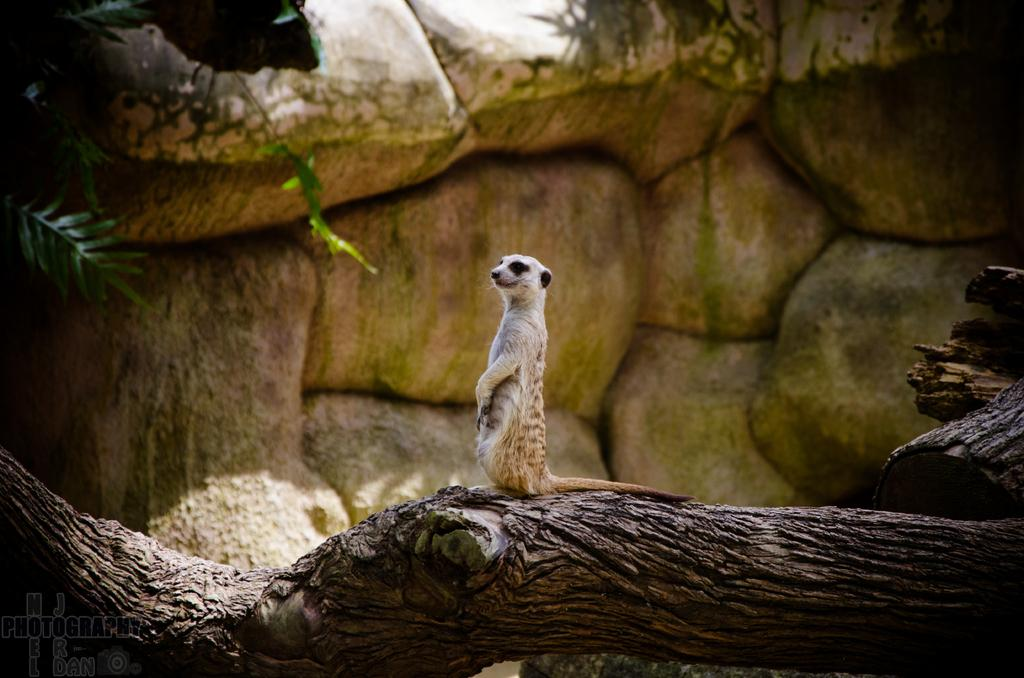What type of animal can be seen in the image? There is an animal in the image, but its specific type cannot be determined from the provided facts. Where is the animal located in the image? The animal is sitting on the trunk of a tree. What can be seen in the background of the image? There are rocks and plants in the background of the image. What songs is the animal singing in the image? There is no indication in the image that the animal is singing any songs. What statement is the animal making in the image? There is no indication in the image that the animal is making any statements. 